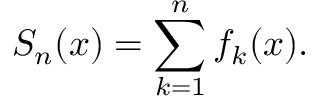Convert formula to latex. <formula><loc_0><loc_0><loc_500><loc_500>S _ { n } ( x ) = \sum _ { k = 1 } ^ { n } f _ { k } ( x ) .</formula> 